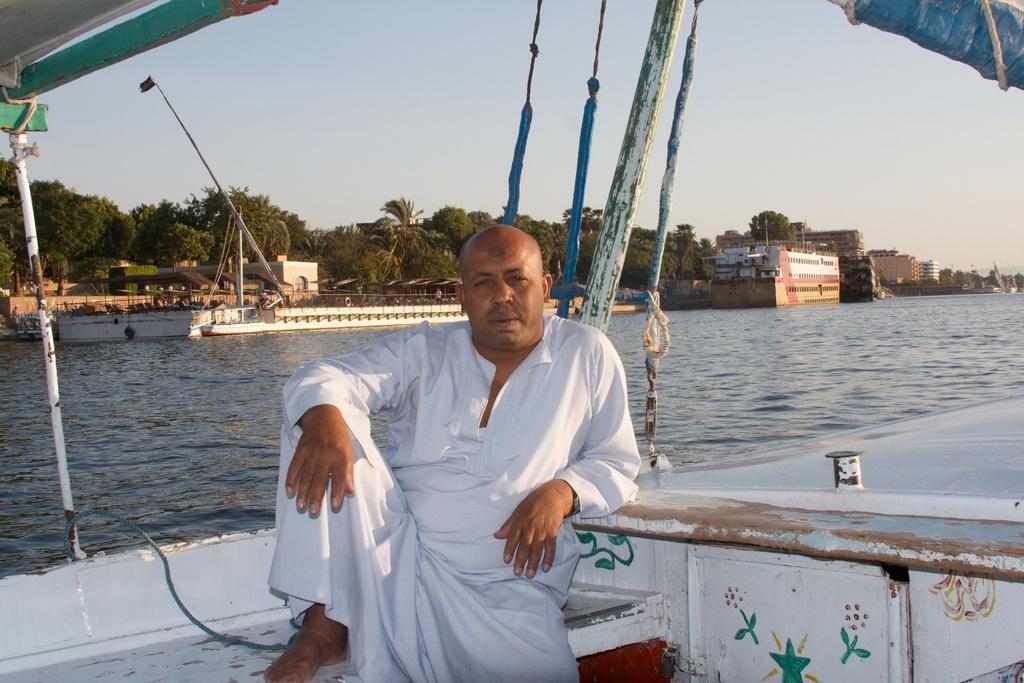In one or two sentences, can you explain what this image depicts? In this picture there is a man who is wearing white dress. He is sitting on the boat. In the background I can see boats, ships, buildings, poles, trees and other objects. At the top there is a sky. On the right I can see the water. 